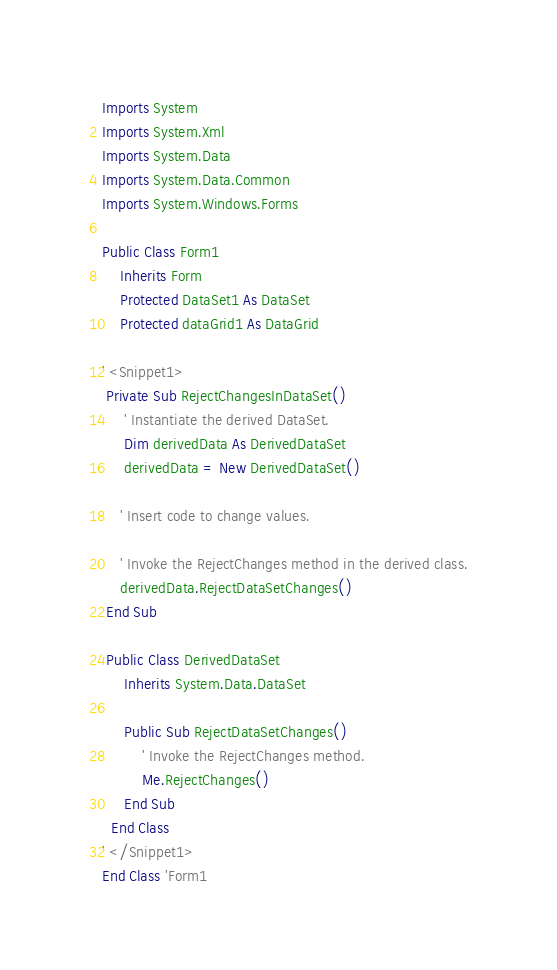<code> <loc_0><loc_0><loc_500><loc_500><_VisualBasic_>Imports System
Imports System.Xml
Imports System.Data
Imports System.Data.Common
Imports System.Windows.Forms

Public Class Form1
    Inherits Form
    Protected DataSet1 As DataSet
    Protected dataGrid1 As DataGrid
    
' <Snippet1>
 Private Sub RejectChangesInDataSet()
     ' Instantiate the derived DataSet.
     Dim derivedData As DerivedDataSet
     derivedData = New DerivedDataSet()

    ' Insert code to change values.

    ' Invoke the RejectChanges method in the derived class.
    derivedData.RejectDataSetChanges()
 End Sub
    
 Public Class DerivedDataSet
     Inherits System.Data.DataSet
      
     Public Sub RejectDataSetChanges()
         ' Invoke the RejectChanges method.
         Me.RejectChanges()
     End Sub
  End Class
' </Snippet1>
End Class 'Form1 



</code> 